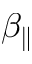Convert formula to latex. <formula><loc_0><loc_0><loc_500><loc_500>\beta _ { \| }</formula> 